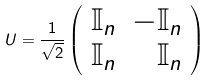Convert formula to latex. <formula><loc_0><loc_0><loc_500><loc_500>U = \frac { 1 } { \sqrt { 2 } } \left ( \begin{array} { l r } \mathbb { I } _ { n } & - \mathbb { I } _ { n } \\ \mathbb { I } _ { n } & \mathbb { I } _ { n } \end{array} \right )</formula> 